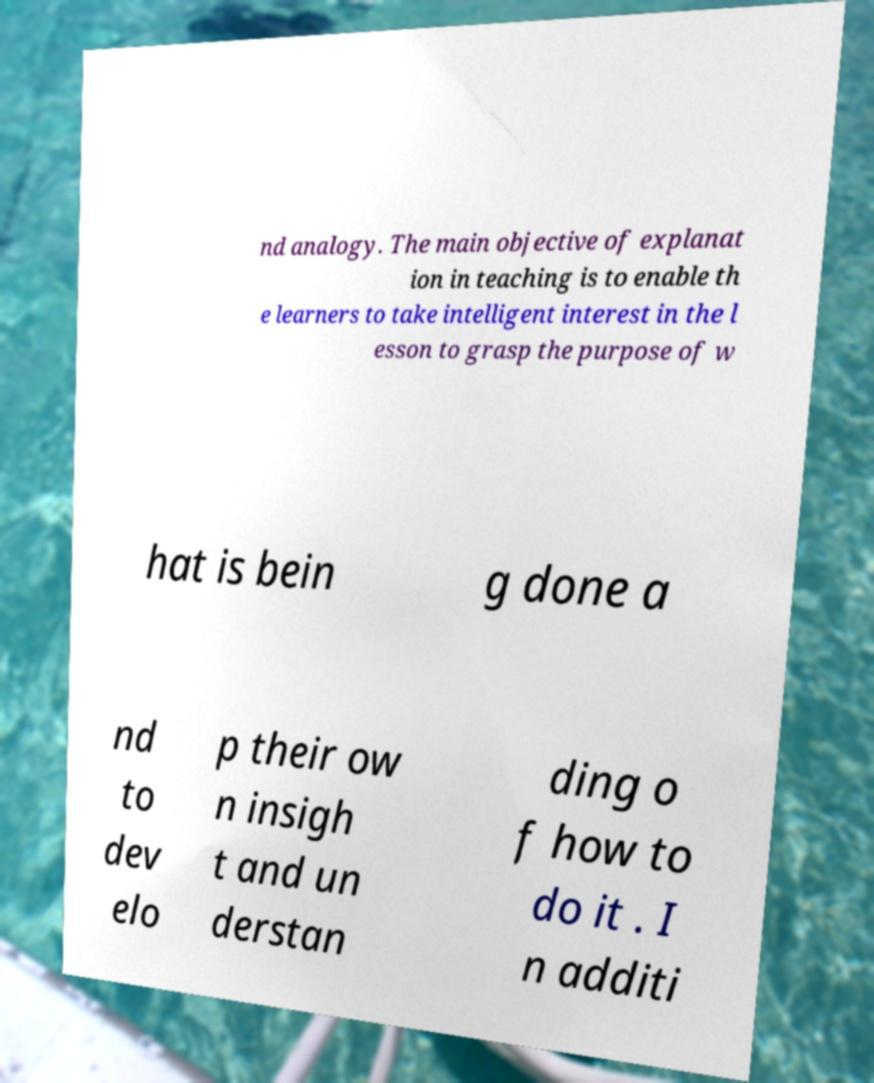What messages or text are displayed in this image? I need them in a readable, typed format. nd analogy. The main objective of explanat ion in teaching is to enable th e learners to take intelligent interest in the l esson to grasp the purpose of w hat is bein g done a nd to dev elo p their ow n insigh t and un derstan ding o f how to do it . I n additi 